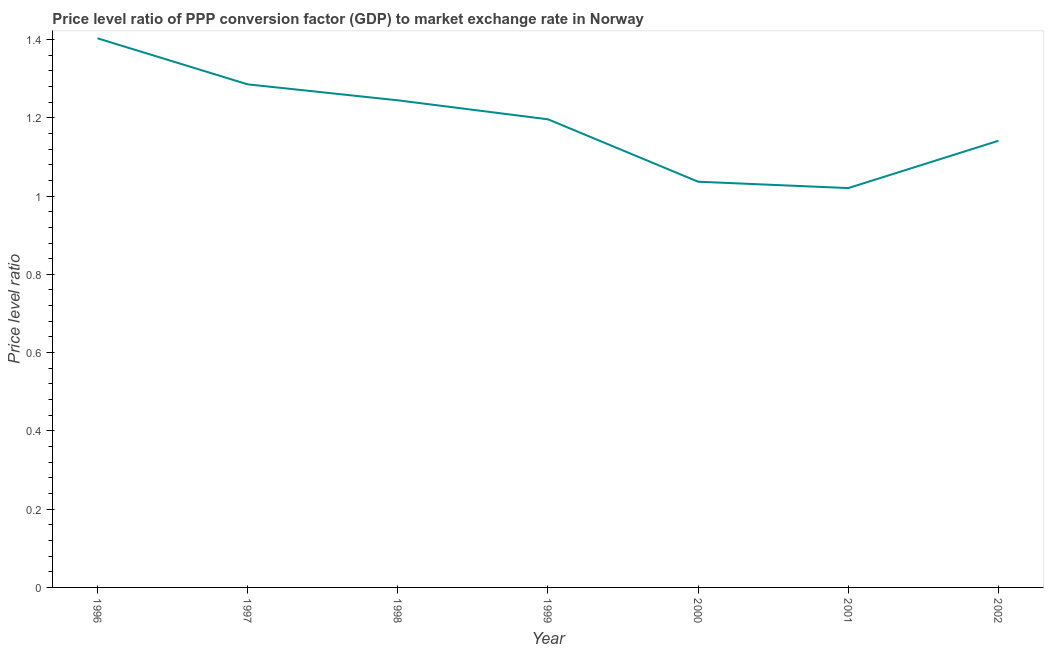What is the price level ratio in 1997?
Your answer should be compact. 1.29. Across all years, what is the maximum price level ratio?
Provide a succinct answer. 1.4. Across all years, what is the minimum price level ratio?
Ensure brevity in your answer.  1.02. What is the sum of the price level ratio?
Provide a short and direct response. 8.33. What is the difference between the price level ratio in 2000 and 2002?
Your response must be concise. -0.1. What is the average price level ratio per year?
Provide a succinct answer. 1.19. What is the median price level ratio?
Provide a short and direct response. 1.2. In how many years, is the price level ratio greater than 0.92 ?
Provide a succinct answer. 7. What is the ratio of the price level ratio in 1997 to that in 2001?
Offer a terse response. 1.26. What is the difference between the highest and the second highest price level ratio?
Offer a very short reply. 0.12. Is the sum of the price level ratio in 1996 and 1998 greater than the maximum price level ratio across all years?
Your response must be concise. Yes. What is the difference between the highest and the lowest price level ratio?
Offer a terse response. 0.38. Does the price level ratio monotonically increase over the years?
Your answer should be very brief. No. Does the graph contain any zero values?
Give a very brief answer. No. What is the title of the graph?
Keep it short and to the point. Price level ratio of PPP conversion factor (GDP) to market exchange rate in Norway. What is the label or title of the X-axis?
Provide a succinct answer. Year. What is the label or title of the Y-axis?
Provide a succinct answer. Price level ratio. What is the Price level ratio of 1996?
Provide a succinct answer. 1.4. What is the Price level ratio of 1997?
Provide a short and direct response. 1.29. What is the Price level ratio of 1998?
Keep it short and to the point. 1.24. What is the Price level ratio in 1999?
Make the answer very short. 1.2. What is the Price level ratio in 2000?
Offer a very short reply. 1.04. What is the Price level ratio of 2001?
Your answer should be very brief. 1.02. What is the Price level ratio of 2002?
Your answer should be very brief. 1.14. What is the difference between the Price level ratio in 1996 and 1997?
Give a very brief answer. 0.12. What is the difference between the Price level ratio in 1996 and 1998?
Offer a terse response. 0.16. What is the difference between the Price level ratio in 1996 and 1999?
Give a very brief answer. 0.21. What is the difference between the Price level ratio in 1996 and 2000?
Provide a short and direct response. 0.37. What is the difference between the Price level ratio in 1996 and 2001?
Keep it short and to the point. 0.38. What is the difference between the Price level ratio in 1996 and 2002?
Give a very brief answer. 0.26. What is the difference between the Price level ratio in 1997 and 1998?
Ensure brevity in your answer.  0.04. What is the difference between the Price level ratio in 1997 and 1999?
Provide a succinct answer. 0.09. What is the difference between the Price level ratio in 1997 and 2000?
Give a very brief answer. 0.25. What is the difference between the Price level ratio in 1997 and 2001?
Your answer should be compact. 0.27. What is the difference between the Price level ratio in 1997 and 2002?
Offer a very short reply. 0.14. What is the difference between the Price level ratio in 1998 and 1999?
Make the answer very short. 0.05. What is the difference between the Price level ratio in 1998 and 2000?
Keep it short and to the point. 0.21. What is the difference between the Price level ratio in 1998 and 2001?
Make the answer very short. 0.22. What is the difference between the Price level ratio in 1998 and 2002?
Provide a succinct answer. 0.1. What is the difference between the Price level ratio in 1999 and 2000?
Your answer should be very brief. 0.16. What is the difference between the Price level ratio in 1999 and 2001?
Provide a succinct answer. 0.18. What is the difference between the Price level ratio in 1999 and 2002?
Your response must be concise. 0.05. What is the difference between the Price level ratio in 2000 and 2001?
Your answer should be very brief. 0.02. What is the difference between the Price level ratio in 2000 and 2002?
Offer a very short reply. -0.1. What is the difference between the Price level ratio in 2001 and 2002?
Provide a short and direct response. -0.12. What is the ratio of the Price level ratio in 1996 to that in 1997?
Offer a very short reply. 1.09. What is the ratio of the Price level ratio in 1996 to that in 1998?
Your response must be concise. 1.13. What is the ratio of the Price level ratio in 1996 to that in 1999?
Provide a succinct answer. 1.17. What is the ratio of the Price level ratio in 1996 to that in 2000?
Make the answer very short. 1.35. What is the ratio of the Price level ratio in 1996 to that in 2001?
Offer a terse response. 1.38. What is the ratio of the Price level ratio in 1996 to that in 2002?
Make the answer very short. 1.23. What is the ratio of the Price level ratio in 1997 to that in 1998?
Provide a short and direct response. 1.03. What is the ratio of the Price level ratio in 1997 to that in 1999?
Provide a succinct answer. 1.07. What is the ratio of the Price level ratio in 1997 to that in 2000?
Offer a very short reply. 1.24. What is the ratio of the Price level ratio in 1997 to that in 2001?
Ensure brevity in your answer.  1.26. What is the ratio of the Price level ratio in 1997 to that in 2002?
Provide a succinct answer. 1.13. What is the ratio of the Price level ratio in 1998 to that in 1999?
Your response must be concise. 1.04. What is the ratio of the Price level ratio in 1998 to that in 2000?
Your answer should be compact. 1.2. What is the ratio of the Price level ratio in 1998 to that in 2001?
Give a very brief answer. 1.22. What is the ratio of the Price level ratio in 1998 to that in 2002?
Provide a succinct answer. 1.09. What is the ratio of the Price level ratio in 1999 to that in 2000?
Offer a very short reply. 1.15. What is the ratio of the Price level ratio in 1999 to that in 2001?
Make the answer very short. 1.17. What is the ratio of the Price level ratio in 1999 to that in 2002?
Offer a terse response. 1.05. What is the ratio of the Price level ratio in 2000 to that in 2002?
Keep it short and to the point. 0.91. What is the ratio of the Price level ratio in 2001 to that in 2002?
Make the answer very short. 0.89. 